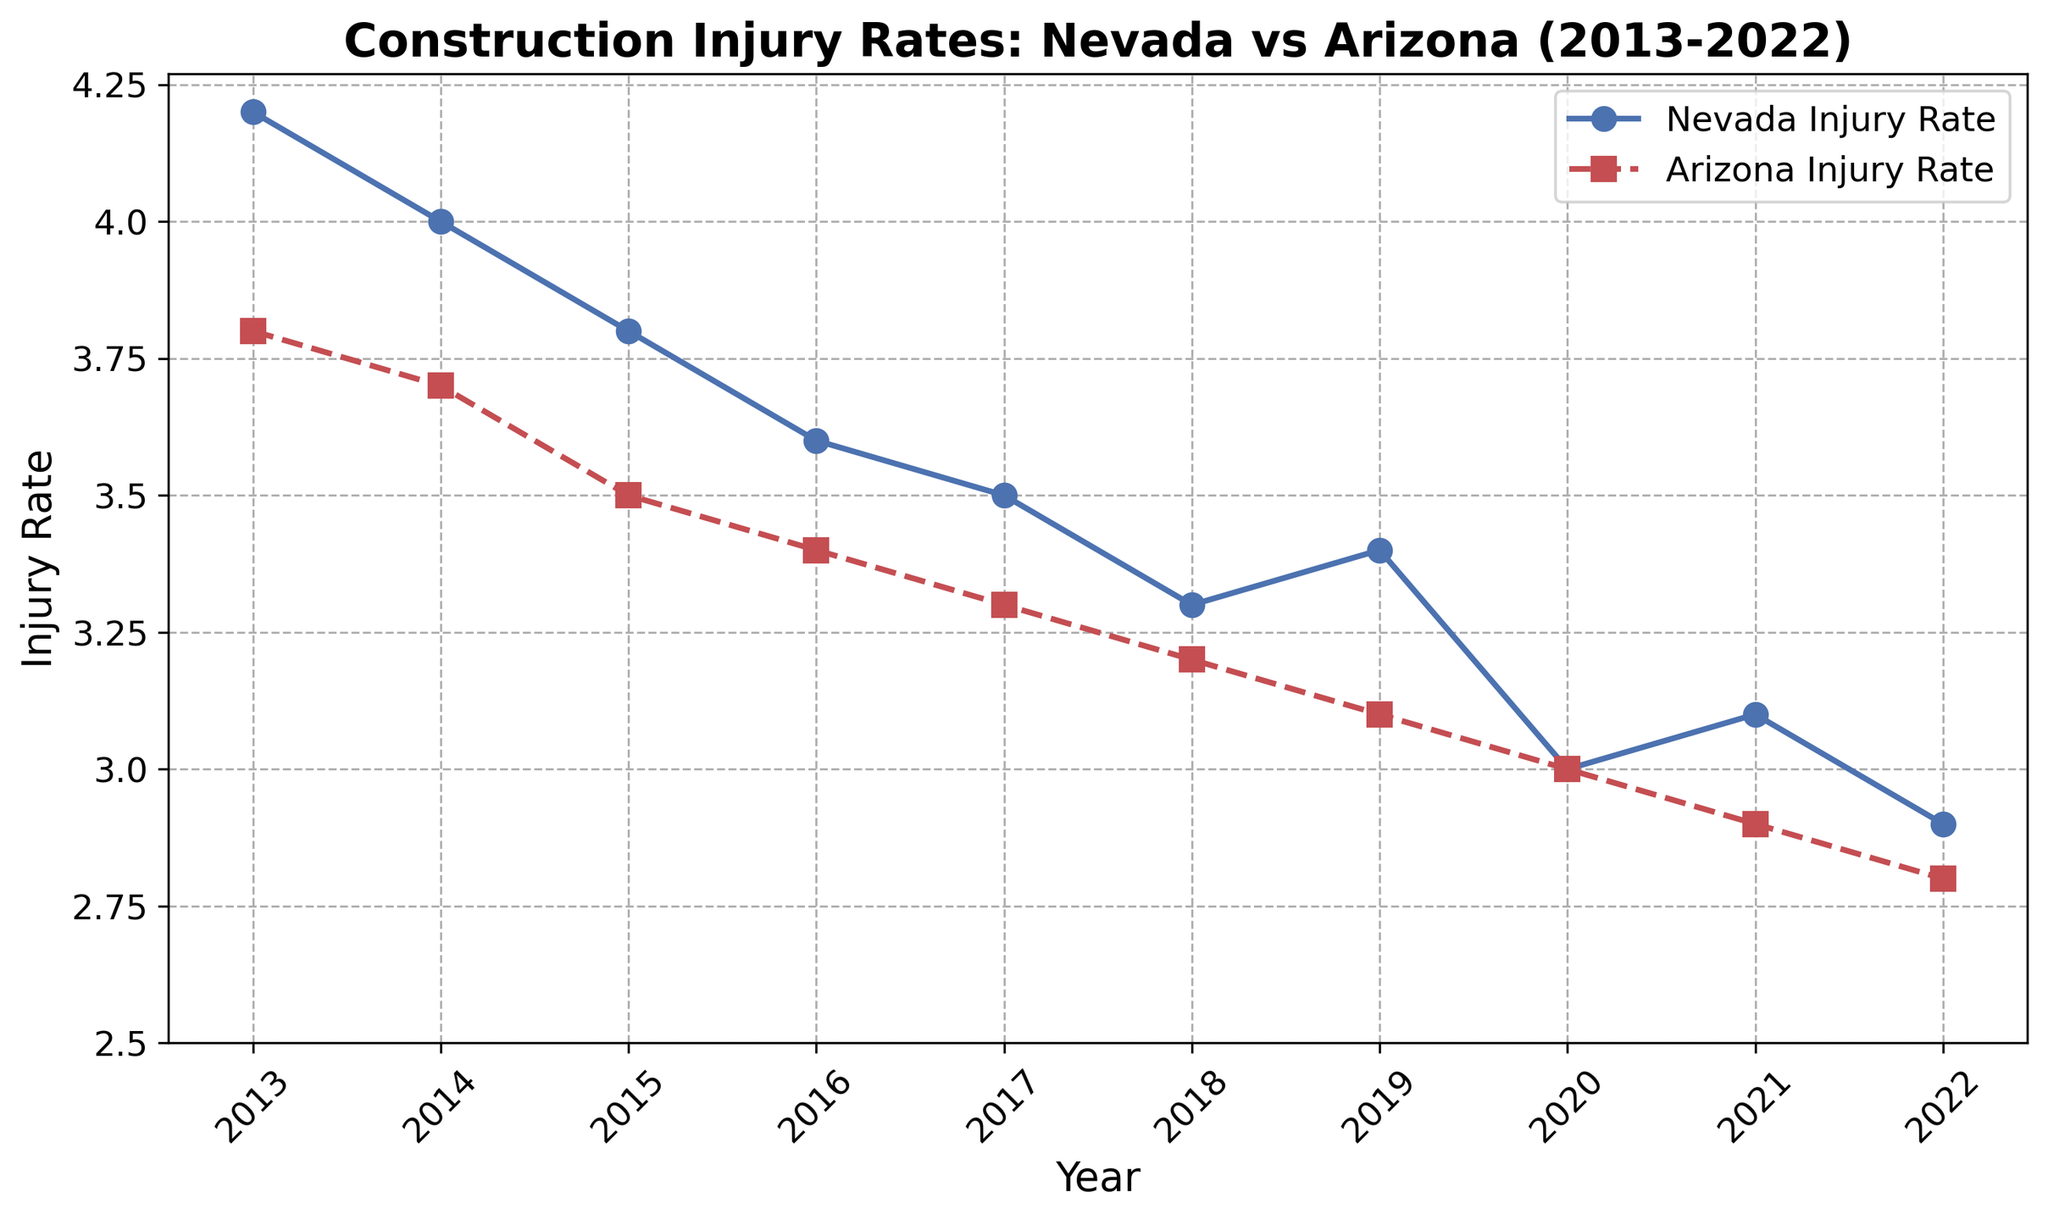What's the trend in the injury rate for Nevada from 2013 to 2022? The line chart shows the injury rate for Nevada decreasing overall from 4.2 in 2013 to 2.9 in 2022.
Answer: Decreasing trend How did the injury rates in Arizona and Nevada compare in 2022? In 2022, Nevada's injury rate was 2.9 and Arizona's injury rate was 2.8, making Arizona's rate slightly lower.
Answer: Arizona's rate is lower Which year had the smallest difference in injury rates between Nevada and Arizona? In 2020, both Nevada and Arizona had the same injury rate of 3.0, leading to the smallest difference, which is zero.
Answer: 2020 What is the mean injury rate for Nevada over the decade? Sum the injury rates for each year from 2013 to 2022 (4.2 + 4.0 + 3.8 + 3.6 + 3.5 + 3.3 + 3.4 + 3.0 + 3.1 + 2.9) = 34.8 and divide by the number of years, which is 10. The mean injury rate is 34.8 / 10 = 3.48.
Answer: 3.48 Is there any year where Arizona's injury rate is higher than Nevada's? By observing the line chart, we see that in all years, the injury rate for Arizona is consistently equal to or lower than that of Nevada.
Answer: No What is the rate of decrease in Nevada's injury rate from 2013 to 2022? Nevada's injury rate in 2013 is 4.2 and in 2022 is 2.9, so the rate of decrease is 4.2 - 2.9 = 1.3
Answer: 1.3 In which year did Arizona achieve the lowest injury rate? The lowest injury rate for Arizona is 2.8, which occurs in the year 2022 as shown in the chart.
Answer: 2022 What are the three consecutive years where Nevada's injury rate has consistently decreased? From the chart, we observe that from 2013 to 2015, Nevada's injury rate decreases consistently from 4.2 to 4.0, then to 3.8.
Answer: 2013-2015 Which state had a greater decline in injury rates from 2016 to 2017? In 2016, Nevada's injury rate was 3.6 and Arizona's was 3.4. In 2017, Nevada's rate was 3.5 and Arizona's was 3.3. The declines are 3.6 - 3.5 = 0.1 for Nevada and 3.4 - 3.3 = 0.1 for Arizona. The declines are equal.
Answer: Equal What is the median injury rate for Arizona over the decade? The sorted injury rates for Arizona from 2013 to 2022 are: 2.8, 2.9, 3.0, 3.1, 3.2, 3.3, 3.4, 3.5, 3.7, 3.8. The median is the average of the 5th and 6th values: (3.2 + 3.3) / 2 = 3.25.
Answer: 3.25 